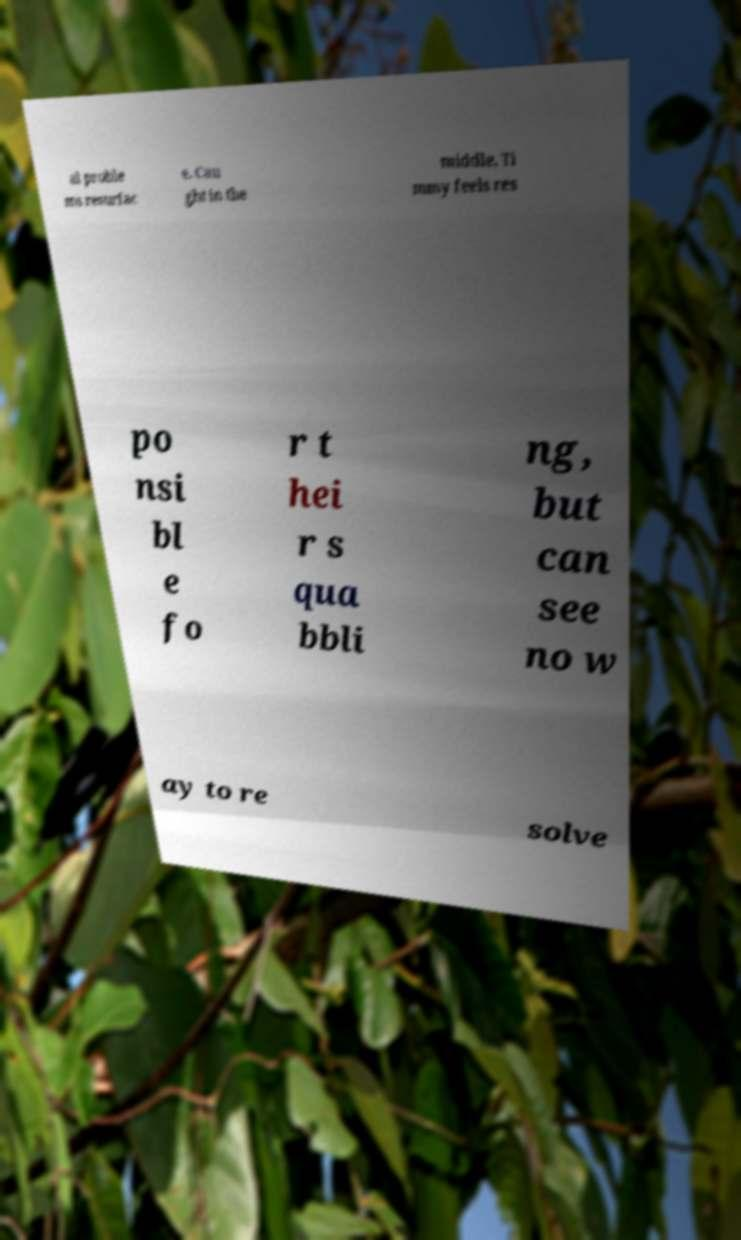There's text embedded in this image that I need extracted. Can you transcribe it verbatim? al proble ms resurfac e. Cau ght in the middle, Ti mmy feels res po nsi bl e fo r t hei r s qua bbli ng, but can see no w ay to re solve 